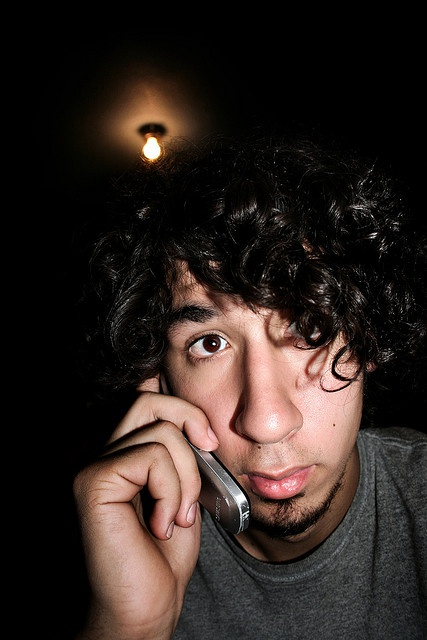Describe the objects in this image and their specific colors. I can see people in black, lightpink, brown, and gray tones and cell phone in black, gray, and darkgray tones in this image. 